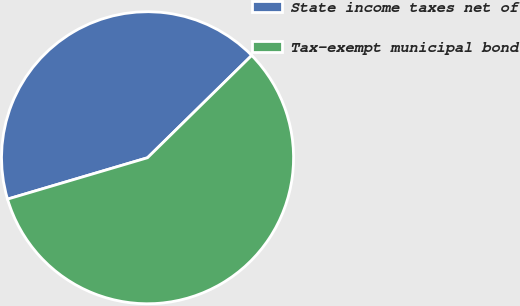Convert chart to OTSL. <chart><loc_0><loc_0><loc_500><loc_500><pie_chart><fcel>State income taxes net of<fcel>Tax-exempt municipal bond<nl><fcel>42.22%<fcel>57.78%<nl></chart> 